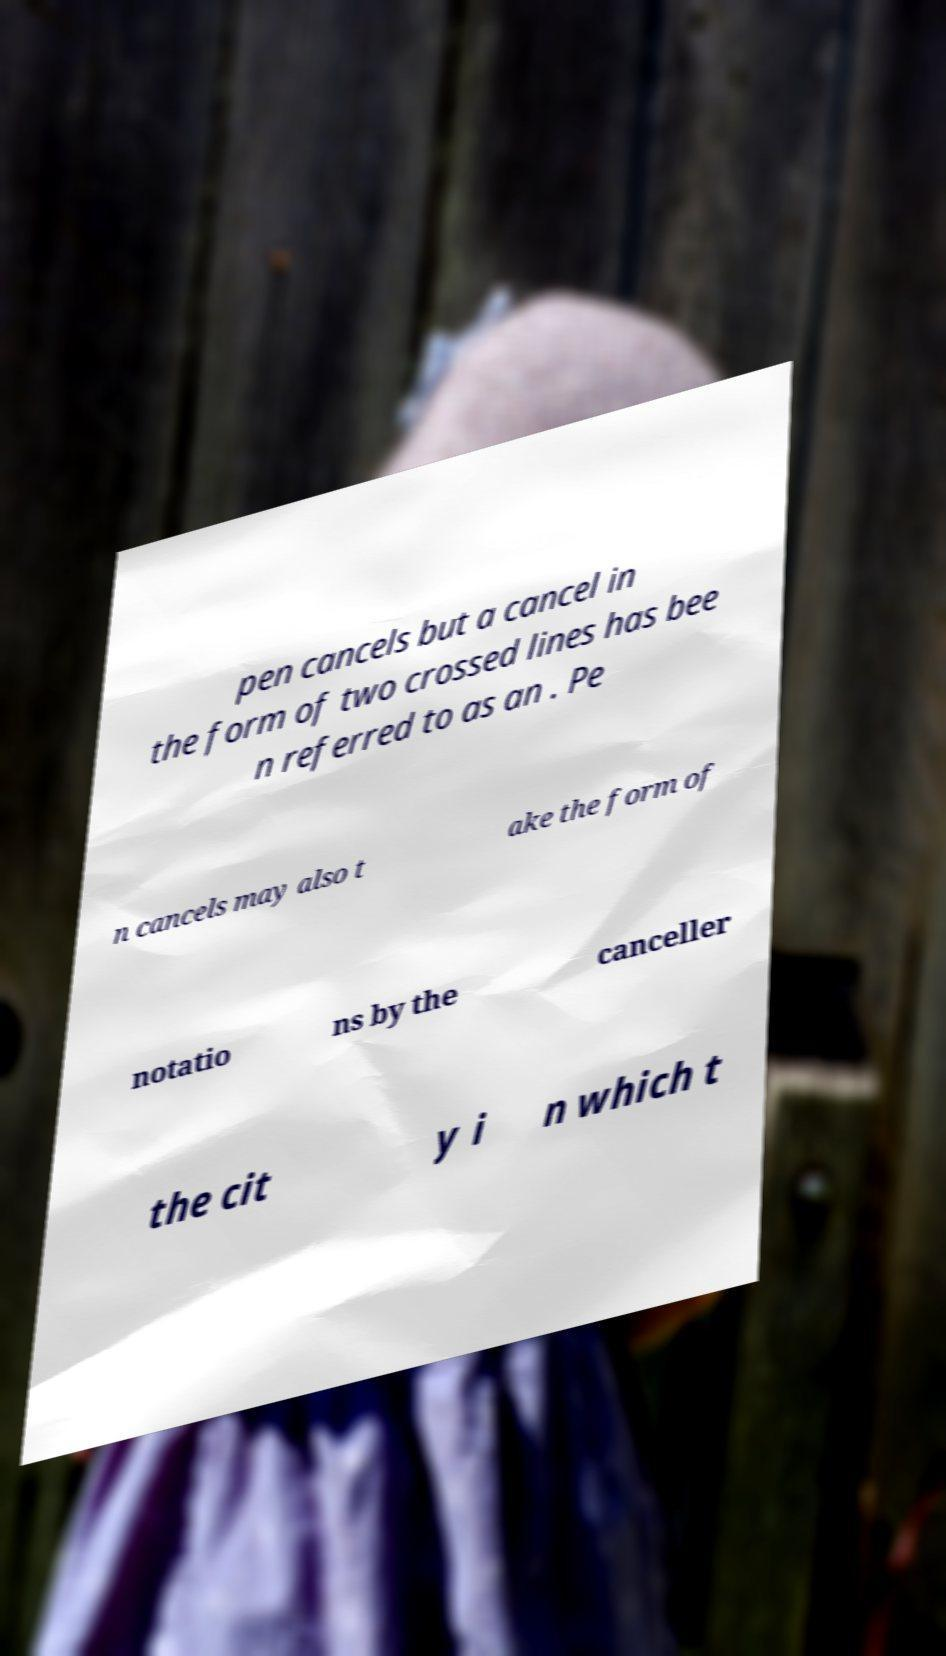Could you assist in decoding the text presented in this image and type it out clearly? pen cancels but a cancel in the form of two crossed lines has bee n referred to as an . Pe n cancels may also t ake the form of notatio ns by the canceller the cit y i n which t 